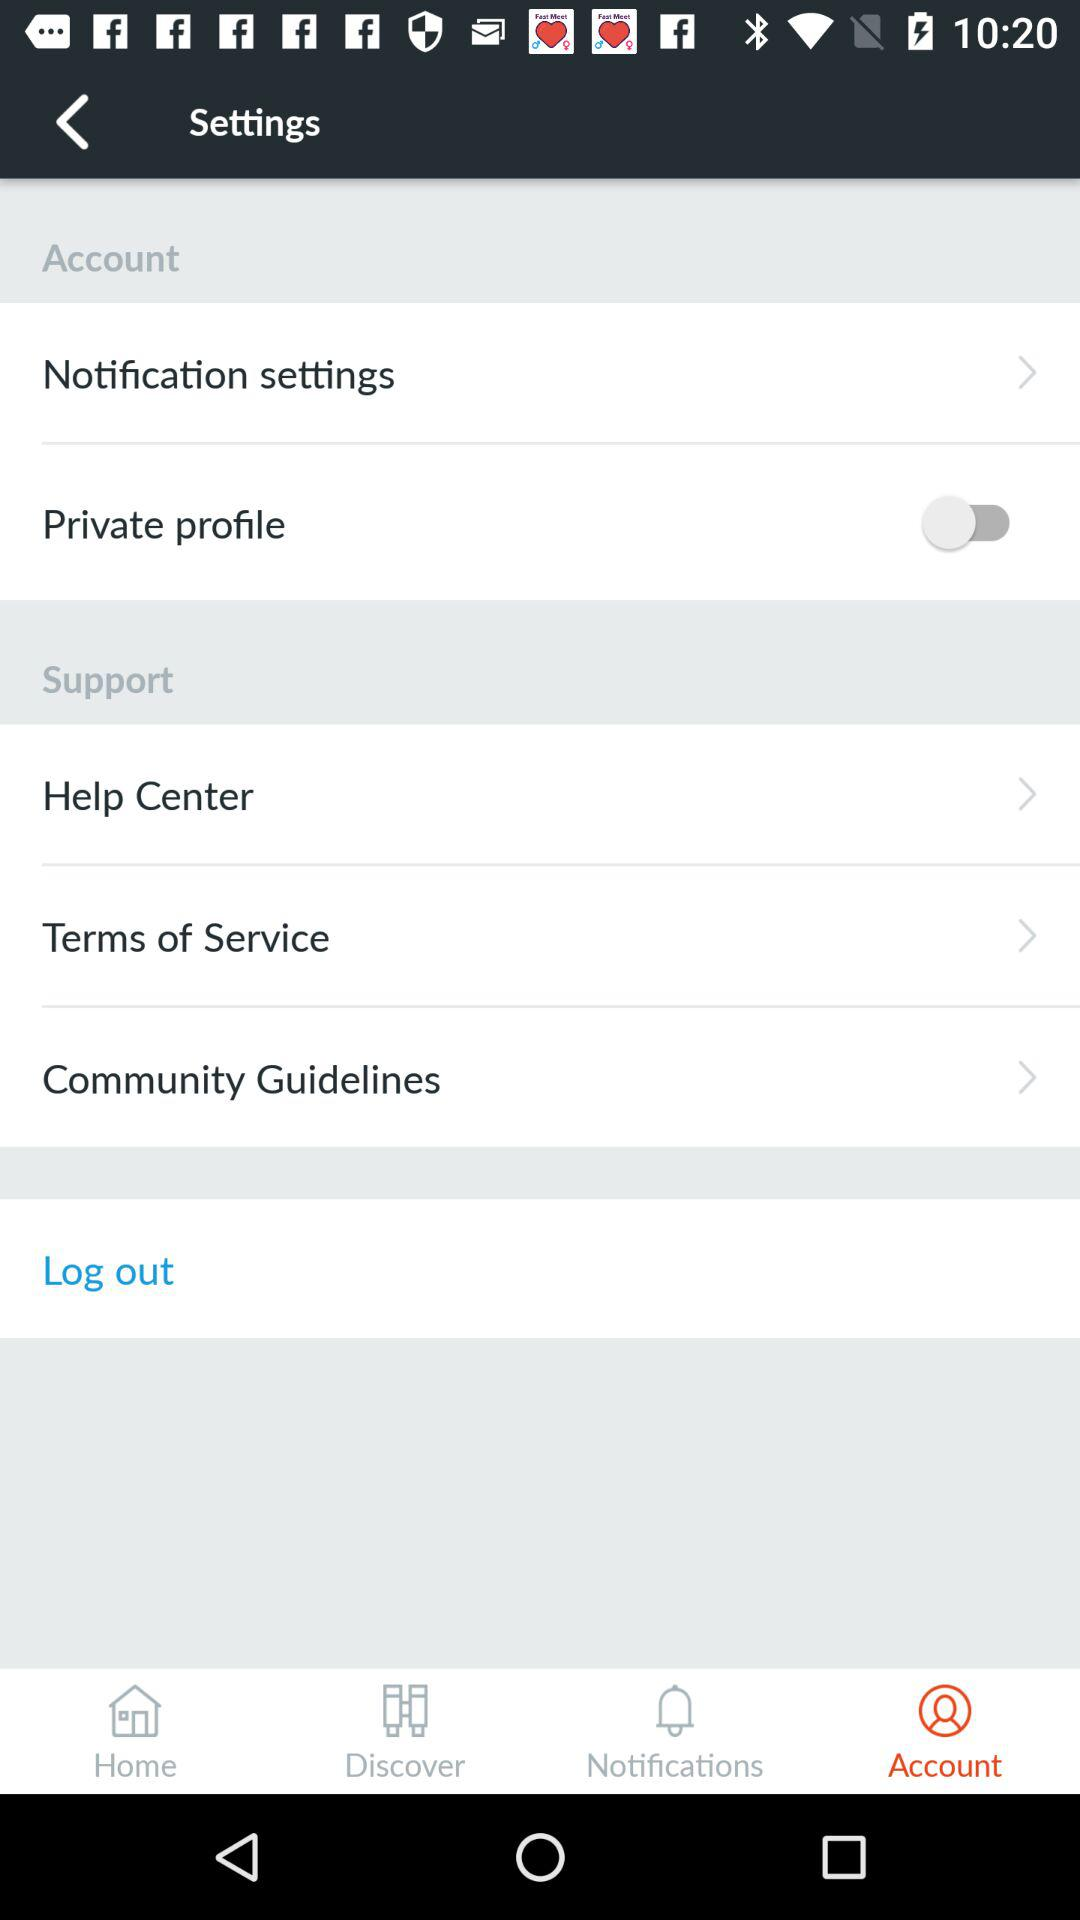When was the last notification sent?
When the provided information is insufficient, respond with <no answer>. <no answer> 